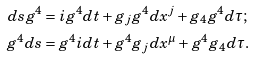<formula> <loc_0><loc_0><loc_500><loc_500>d s g ^ { 4 } & = i g ^ { 4 } d t + g _ { j } g ^ { 4 } d x ^ { j } + g _ { 4 } g ^ { 4 } d \tau ; \\ g ^ { 4 } d s & = g ^ { 4 } i d t + g ^ { 4 } g _ { j } d x ^ { \mu } + g ^ { 4 } g _ { 4 } d \tau .</formula> 